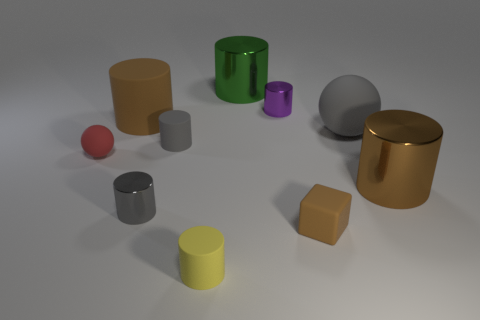There is a big brown cylinder that is to the right of the large green metal cylinder; is there a large gray rubber object to the left of it?
Keep it short and to the point. Yes. There is a tiny purple shiny object; does it have the same shape as the tiny metal thing that is to the left of the yellow cylinder?
Give a very brief answer. Yes. What is the color of the sphere that is in front of the large ball?
Provide a succinct answer. Red. How big is the brown cylinder in front of the large brown cylinder behind the big brown metal cylinder?
Your answer should be compact. Large. There is a large metallic object in front of the green shiny thing; does it have the same shape as the small brown matte thing?
Ensure brevity in your answer.  No. What material is the gray thing that is the same shape as the small red rubber thing?
Offer a terse response. Rubber. What number of things are either gray cylinders behind the small red matte thing or objects that are behind the red sphere?
Provide a succinct answer. 5. Is the color of the small cube the same as the big shiny cylinder that is in front of the large brown matte thing?
Make the answer very short. Yes. What is the shape of the tiny brown object that is made of the same material as the small yellow cylinder?
Your response must be concise. Cube. What number of small brown things are there?
Your answer should be compact. 1. 